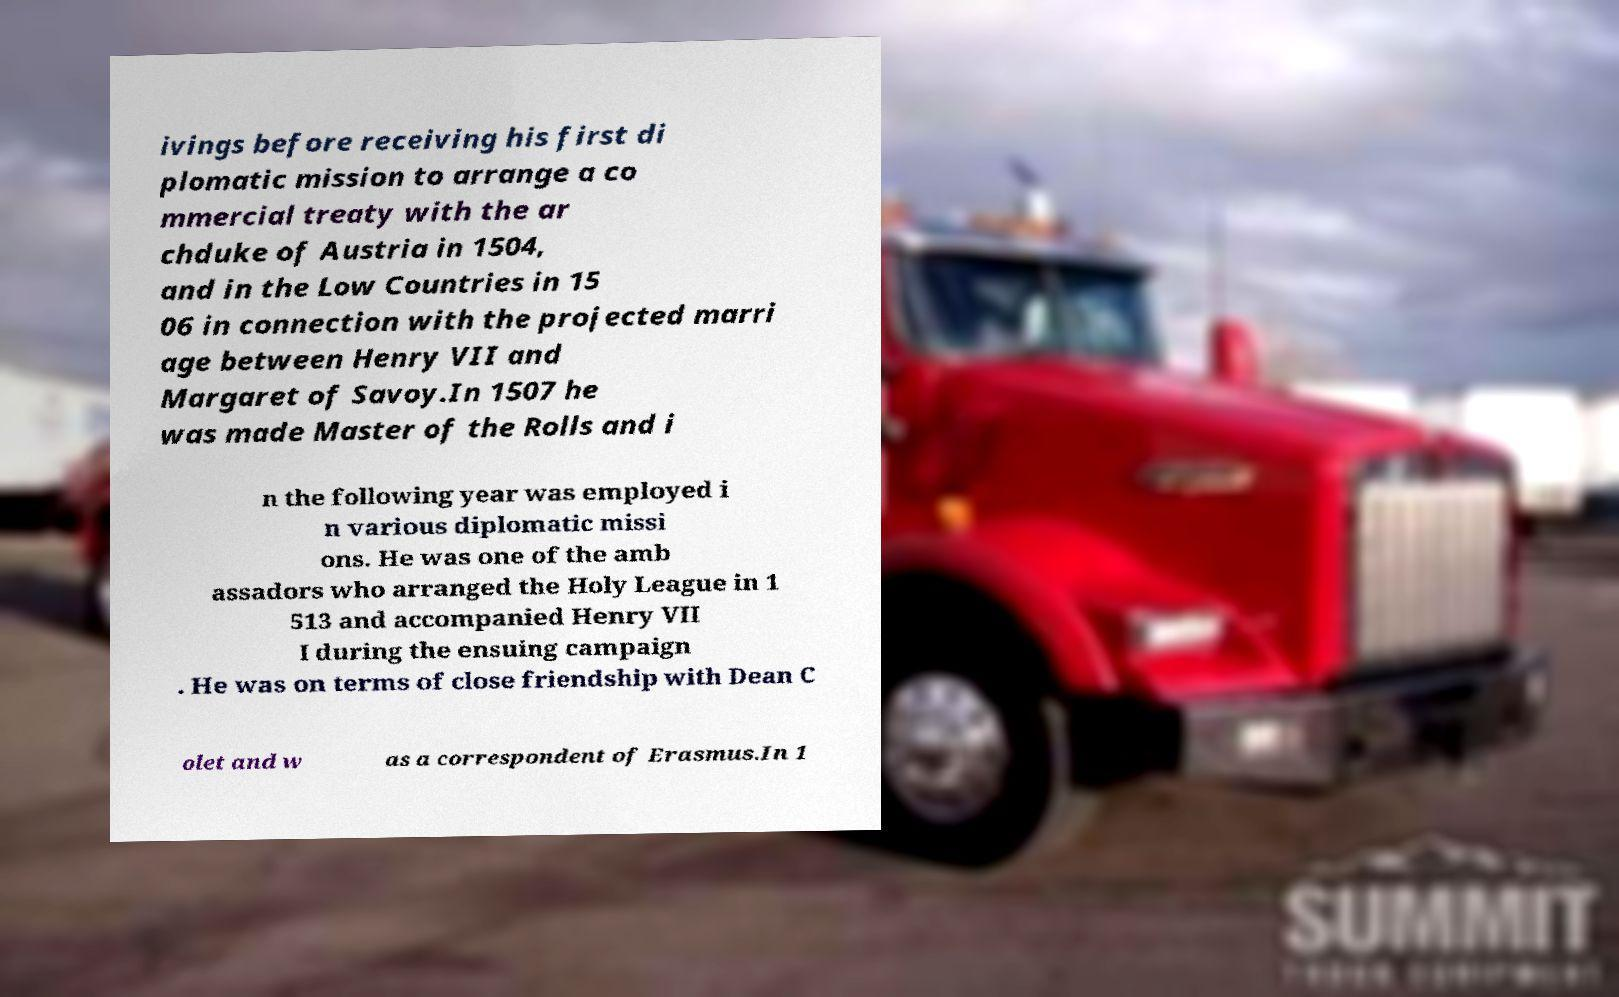I need the written content from this picture converted into text. Can you do that? ivings before receiving his first di plomatic mission to arrange a co mmercial treaty with the ar chduke of Austria in 1504, and in the Low Countries in 15 06 in connection with the projected marri age between Henry VII and Margaret of Savoy.In 1507 he was made Master of the Rolls and i n the following year was employed i n various diplomatic missi ons. He was one of the amb assadors who arranged the Holy League in 1 513 and accompanied Henry VII I during the ensuing campaign . He was on terms of close friendship with Dean C olet and w as a correspondent of Erasmus.In 1 